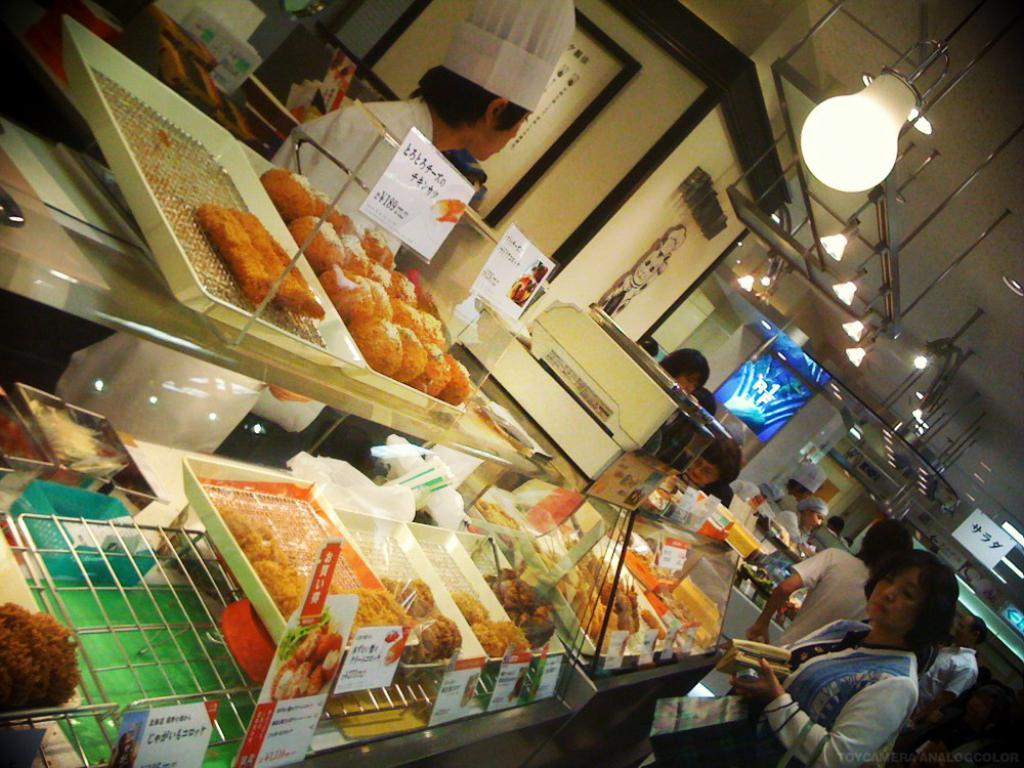What is happening in the foreground of the image? There is a group of people in the foreground of the image. What can be seen on the table in the foreground? There are food items on trays on a table in the foreground. What is visible in the background of the image? There is a wall, metal rods, and lamps visible in the background. Where was the image taken? The image was taken in a hotel. How many cats are sitting on the table in the image? There are no cats present in the image. What type of print is visible on the wall in the background? There is no print visible on the wall in the background; only a plain wall is present. 